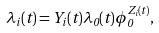Convert formula to latex. <formula><loc_0><loc_0><loc_500><loc_500>\lambda _ { i } ( t ) = Y _ { i } ( t ) \lambda _ { 0 } ( t ) \phi _ { 0 } ^ { Z _ { i } ( t ) } ,</formula> 